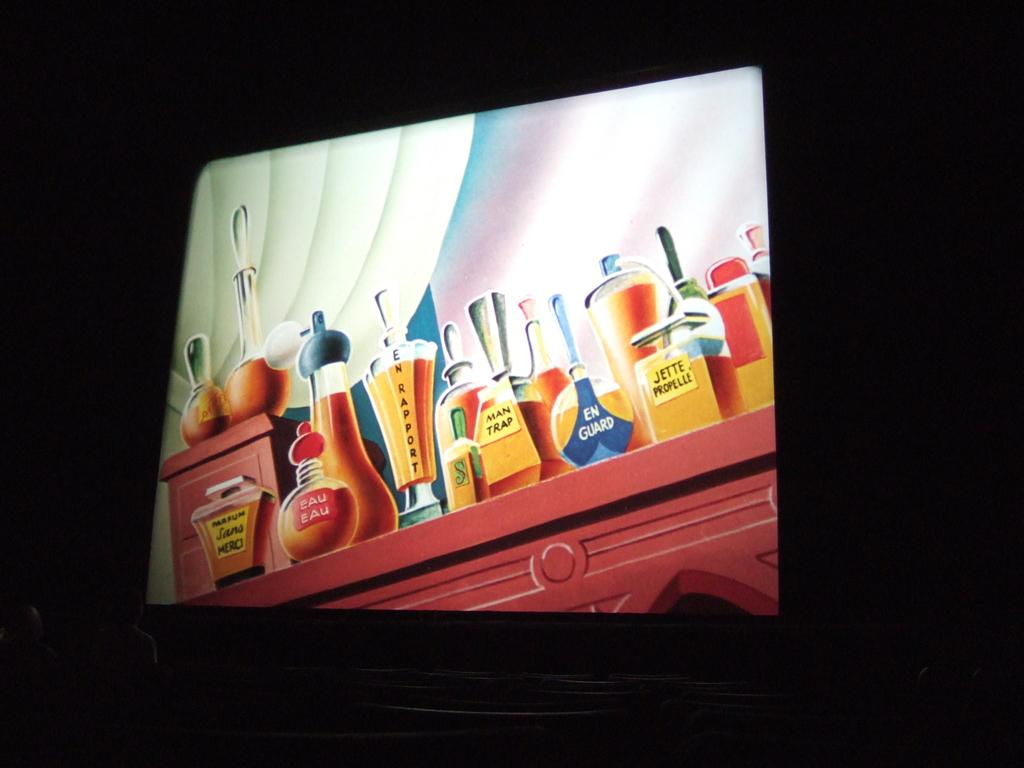What does this blue label say?
Provide a succinct answer. En guard. What does the rightmost yellow label say?
Provide a succinct answer. Jette propelle. 